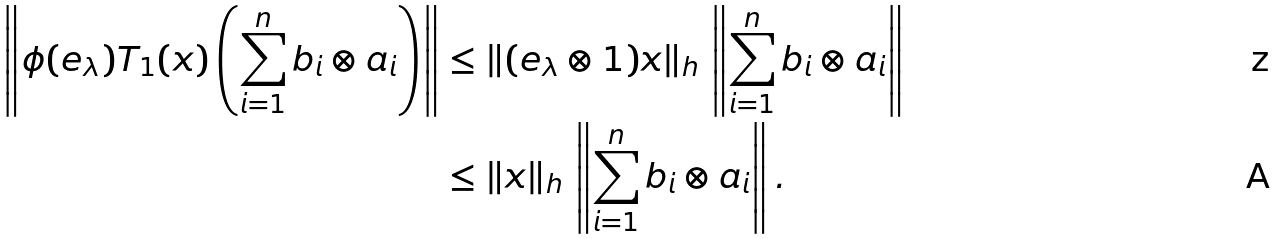<formula> <loc_0><loc_0><loc_500><loc_500>\left \| \phi ( e _ { \lambda } ) T _ { 1 } ( x ) \left ( \sum _ { i = 1 } ^ { n } b _ { i } \otimes a _ { i } \right ) \right \| & \leq \| ( e _ { \lambda } \otimes 1 ) x \| _ { h } \, \left \| \sum _ { i = 1 } ^ { n } b _ { i } \otimes a _ { i } \right \| \\ & \leq \| x \| _ { h } \, \left \| \sum _ { i = 1 } ^ { n } b _ { i } \otimes a _ { i } \right \| .</formula> 